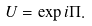Convert formula to latex. <formula><loc_0><loc_0><loc_500><loc_500>U = \exp i \Pi .</formula> 